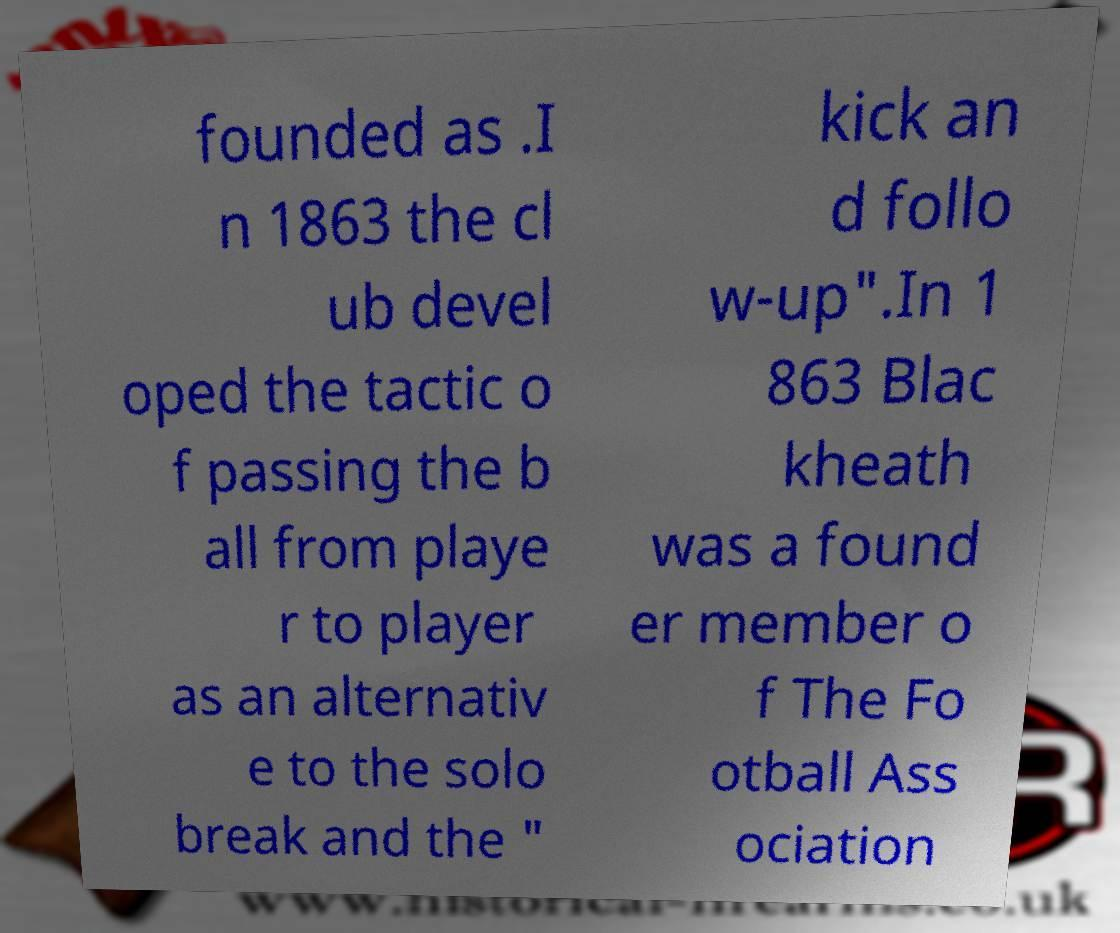What messages or text are displayed in this image? I need them in a readable, typed format. founded as .I n 1863 the cl ub devel oped the tactic o f passing the b all from playe r to player as an alternativ e to the solo break and the " kick an d follo w-up".In 1 863 Blac kheath was a found er member o f The Fo otball Ass ociation 